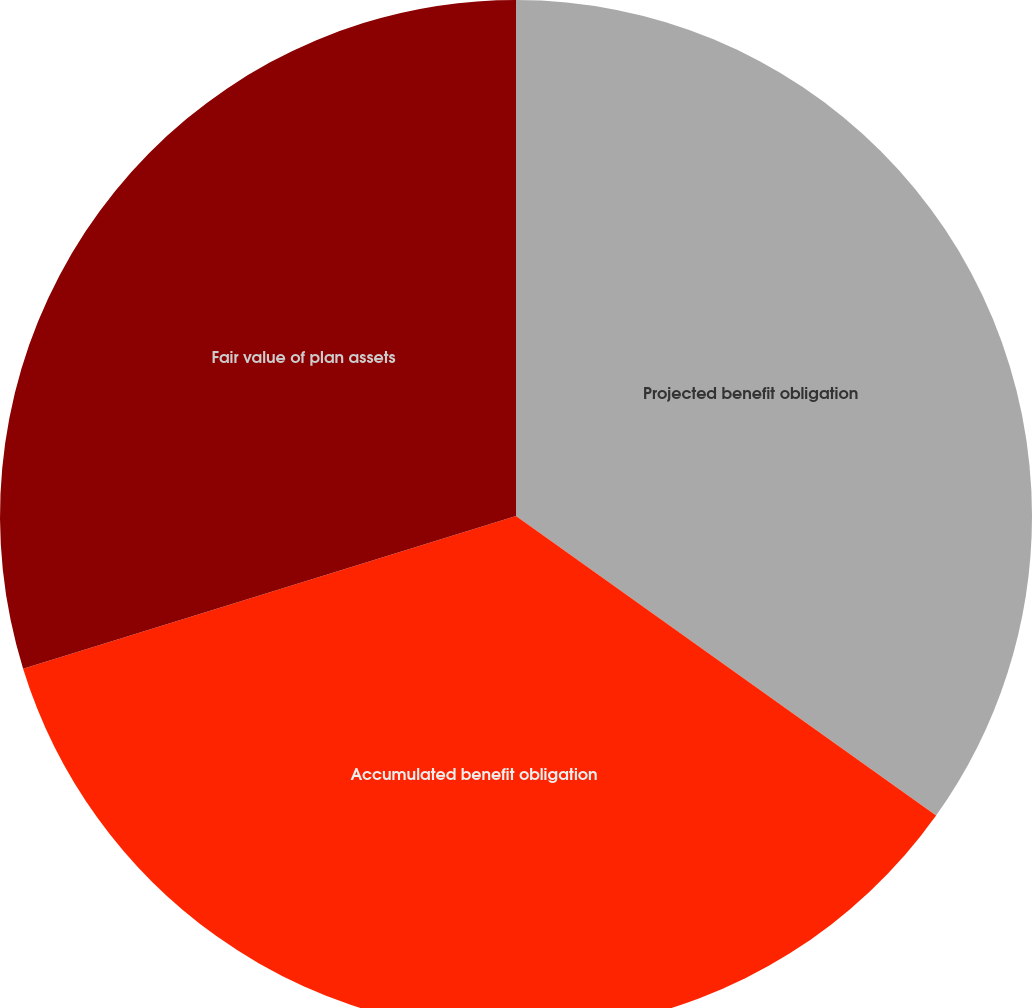Convert chart to OTSL. <chart><loc_0><loc_0><loc_500><loc_500><pie_chart><fcel>Projected benefit obligation<fcel>Accumulated benefit obligation<fcel>Fair value of plan assets<nl><fcel>34.86%<fcel>35.36%<fcel>29.78%<nl></chart> 